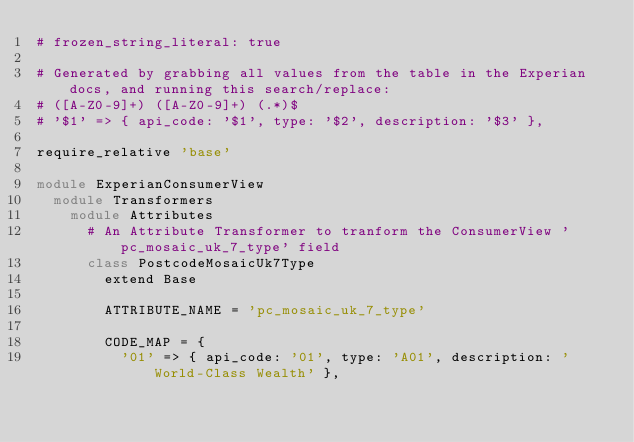Convert code to text. <code><loc_0><loc_0><loc_500><loc_500><_Ruby_># frozen_string_literal: true

# Generated by grabbing all values from the table in the Experian docs, and running this search/replace:
# ([A-Z0-9]+) ([A-Z0-9]+) (.*)$
# '$1' => { api_code: '$1', type: '$2', description: '$3' },

require_relative 'base'

module ExperianConsumerView
  module Transformers
    module Attributes
      # An Attribute Transformer to tranform the ConsumerView 'pc_mosaic_uk_7_type' field
      class PostcodeMosaicUk7Type
        extend Base

        ATTRIBUTE_NAME = 'pc_mosaic_uk_7_type'

        CODE_MAP = {
          '01' => { api_code: '01', type: 'A01', description: 'World-Class Wealth' },</code> 